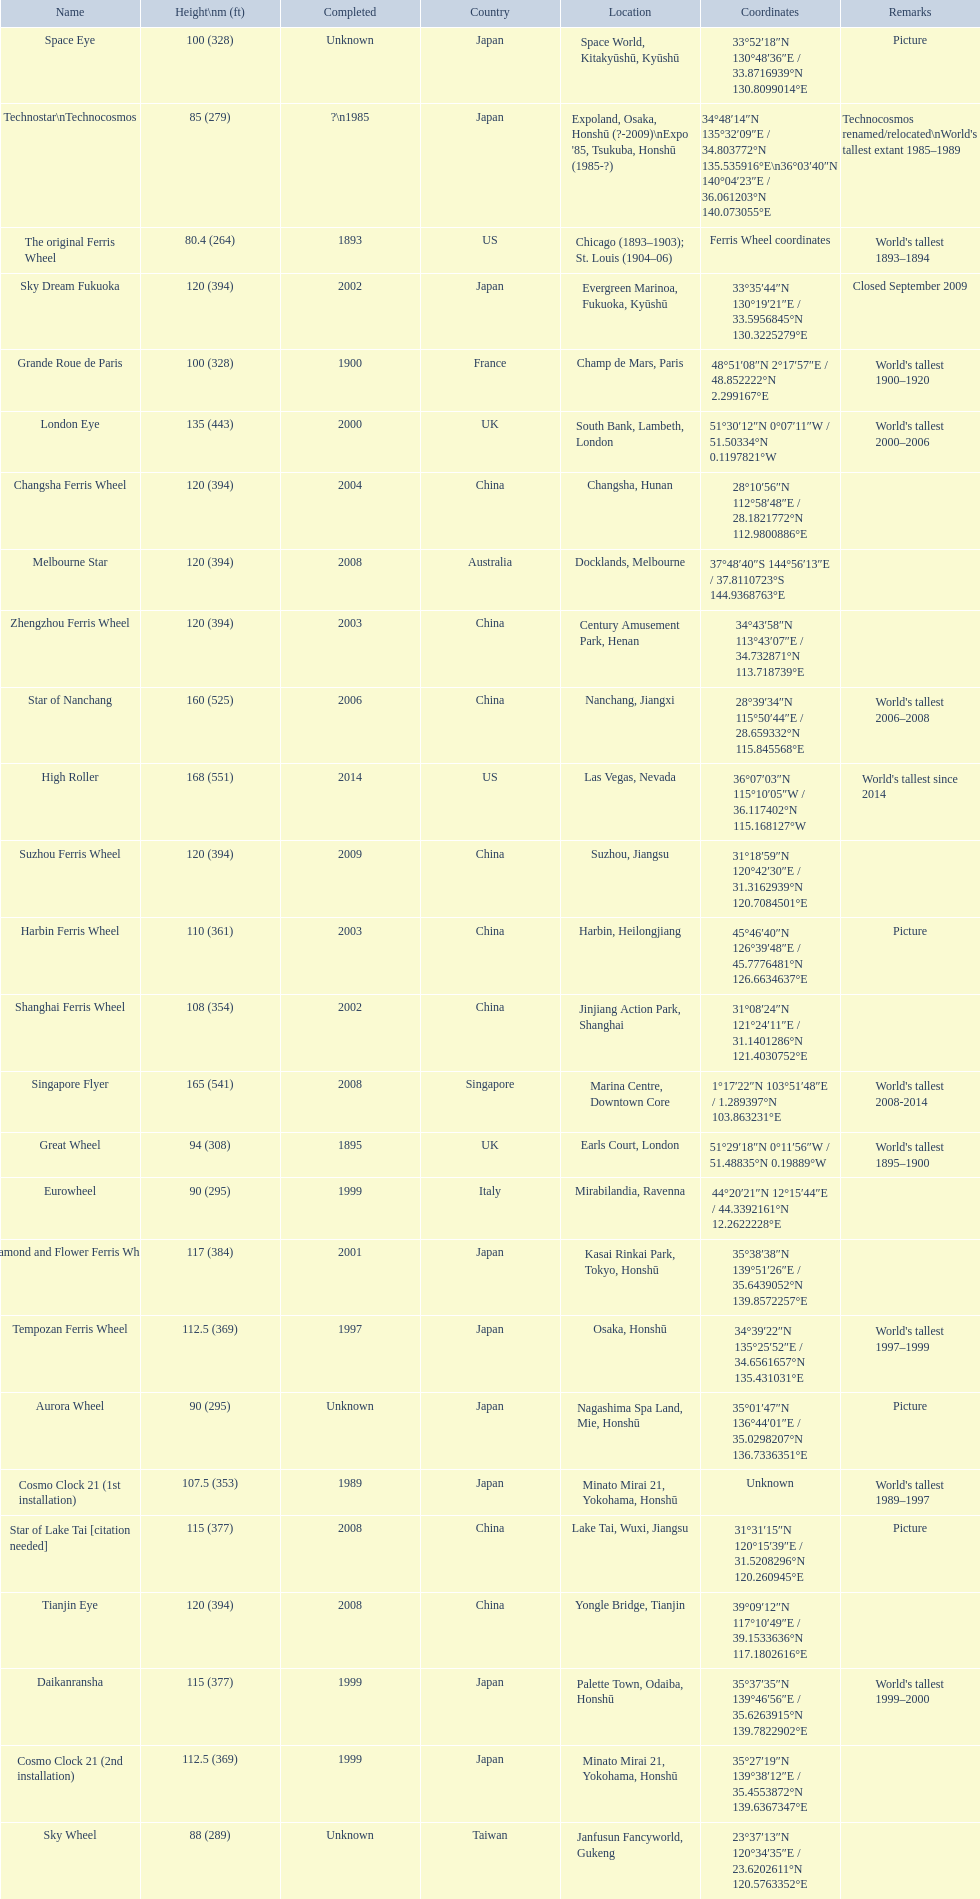What are the different completion dates for the ferris wheel list? 2014, 2008, 2006, 2000, 2009, 2008, 2008, 2004, 2003, 2002, 2001, 2008, 1999, 1999, 1997, 2003, 2002, 1989, Unknown, 1900, 1895, Unknown, 1999, Unknown, ?\n1985, 1893. Which dates for the star of lake tai, star of nanchang, melbourne star? 2006, 2008, 2008. Which is the oldest? 2006. What ride name is this for? Star of Nanchang. 